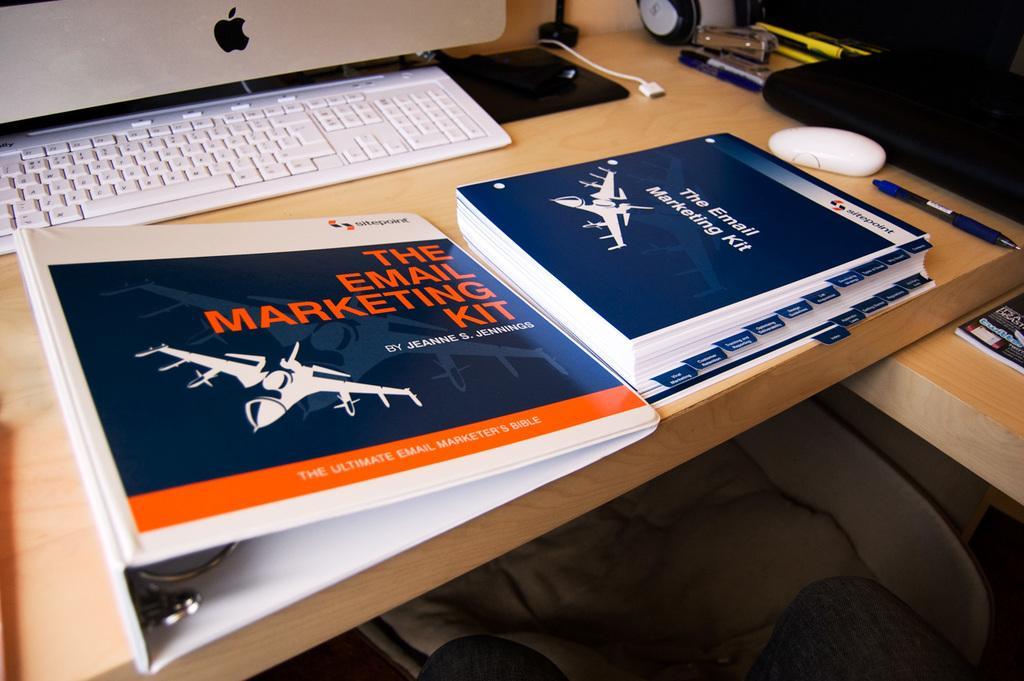Describe this image in one or two sentences. In a picture there is a table on which there are books,mouse,pen and keyboard,monitor are present and there is a chair under the bench. 